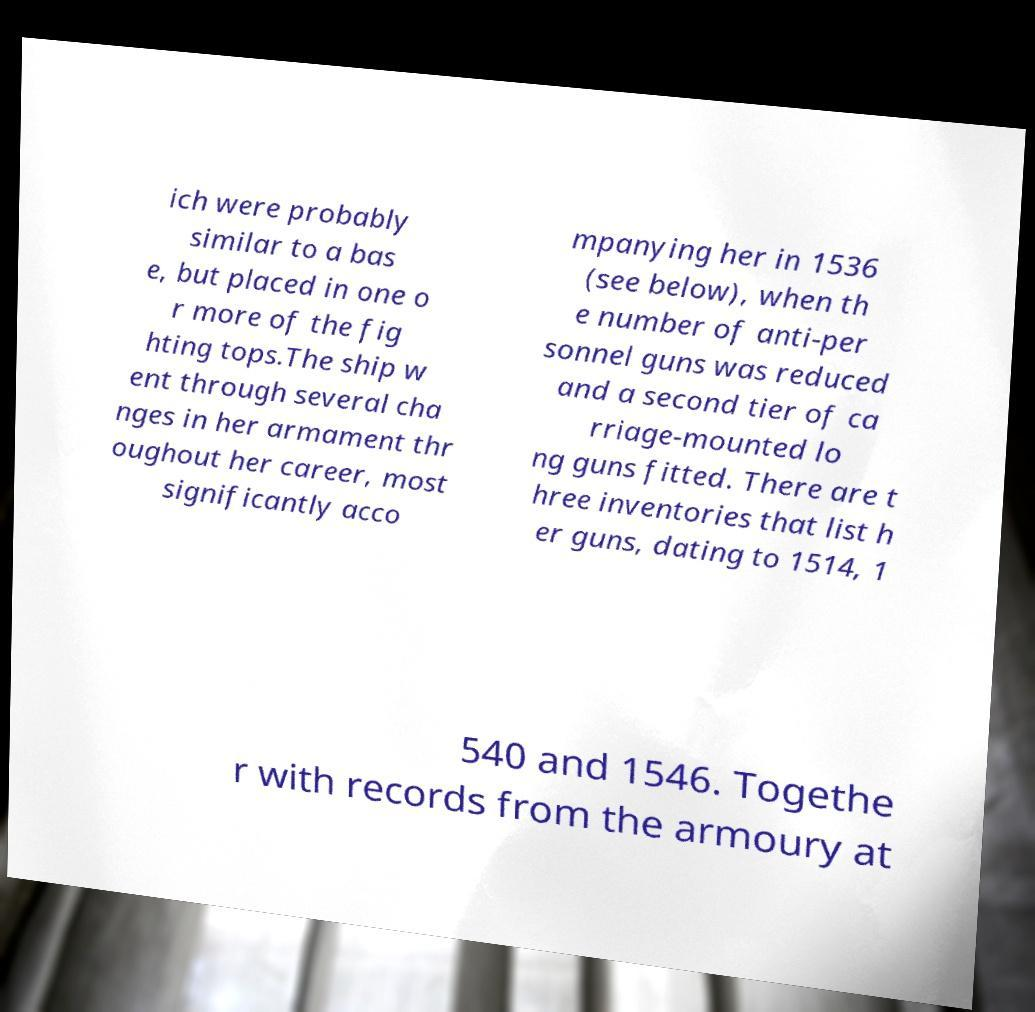What messages or text are displayed in this image? I need them in a readable, typed format. ich were probably similar to a bas e, but placed in one o r more of the fig hting tops.The ship w ent through several cha nges in her armament thr oughout her career, most significantly acco mpanying her in 1536 (see below), when th e number of anti-per sonnel guns was reduced and a second tier of ca rriage-mounted lo ng guns fitted. There are t hree inventories that list h er guns, dating to 1514, 1 540 and 1546. Togethe r with records from the armoury at 